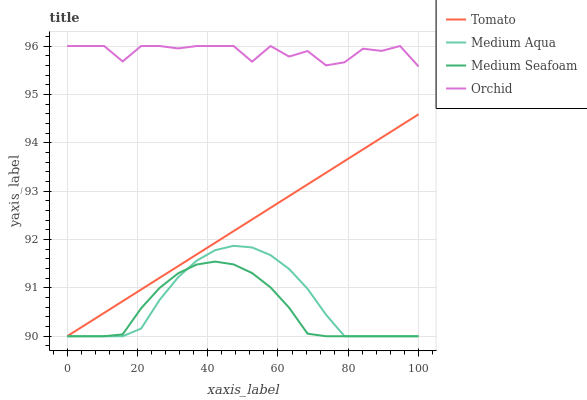Does Medium Seafoam have the minimum area under the curve?
Answer yes or no. Yes. Does Orchid have the maximum area under the curve?
Answer yes or no. Yes. Does Medium Aqua have the minimum area under the curve?
Answer yes or no. No. Does Medium Aqua have the maximum area under the curve?
Answer yes or no. No. Is Tomato the smoothest?
Answer yes or no. Yes. Is Orchid the roughest?
Answer yes or no. Yes. Is Medium Aqua the smoothest?
Answer yes or no. No. Is Medium Aqua the roughest?
Answer yes or no. No. Does Tomato have the lowest value?
Answer yes or no. Yes. Does Orchid have the lowest value?
Answer yes or no. No. Does Orchid have the highest value?
Answer yes or no. Yes. Does Medium Aqua have the highest value?
Answer yes or no. No. Is Medium Seafoam less than Orchid?
Answer yes or no. Yes. Is Orchid greater than Medium Aqua?
Answer yes or no. Yes. Does Medium Seafoam intersect Tomato?
Answer yes or no. Yes. Is Medium Seafoam less than Tomato?
Answer yes or no. No. Is Medium Seafoam greater than Tomato?
Answer yes or no. No. Does Medium Seafoam intersect Orchid?
Answer yes or no. No. 